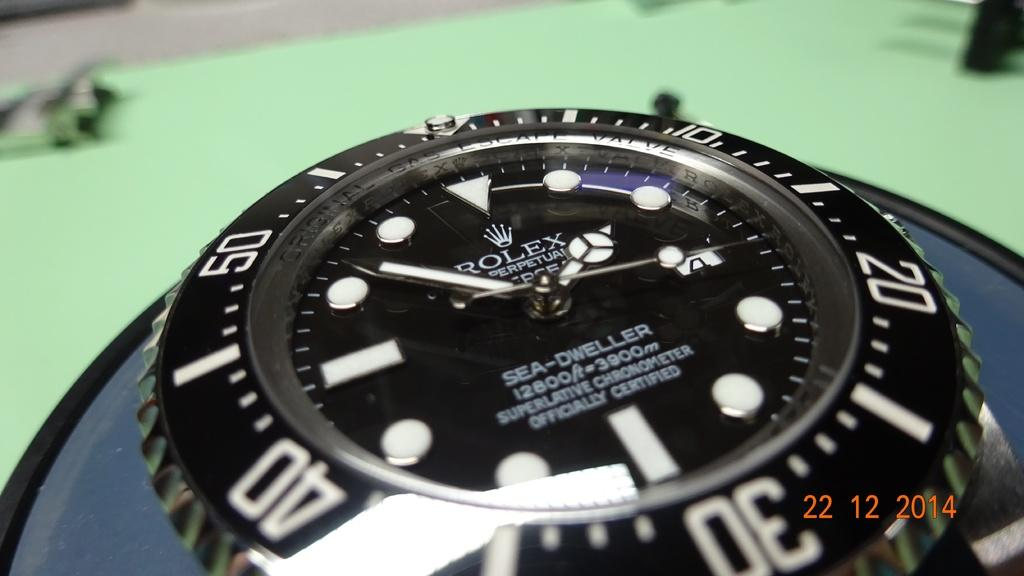<image>
Create a compact narrative representing the image presented. A watch from rolex with the time 1:51 as the time. 